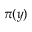<formula> <loc_0><loc_0><loc_500><loc_500>\pi ( y )</formula> 